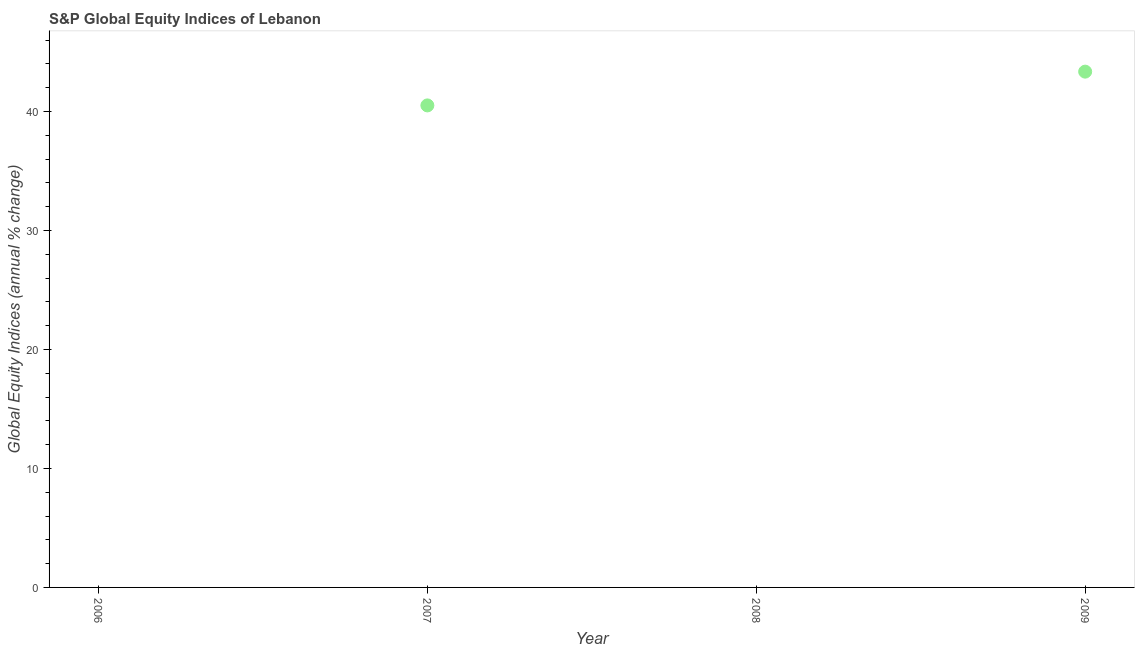Across all years, what is the maximum s&p global equity indices?
Offer a very short reply. 43.36. What is the sum of the s&p global equity indices?
Provide a succinct answer. 83.88. What is the difference between the s&p global equity indices in 2007 and 2009?
Make the answer very short. -2.84. What is the average s&p global equity indices per year?
Make the answer very short. 20.97. What is the median s&p global equity indices?
Your response must be concise. 20.26. In how many years, is the s&p global equity indices greater than 40 %?
Give a very brief answer. 2. What is the ratio of the s&p global equity indices in 2007 to that in 2009?
Offer a very short reply. 0.93. Is the sum of the s&p global equity indices in 2007 and 2009 greater than the maximum s&p global equity indices across all years?
Give a very brief answer. Yes. What is the difference between the highest and the lowest s&p global equity indices?
Your answer should be compact. 43.36. In how many years, is the s&p global equity indices greater than the average s&p global equity indices taken over all years?
Offer a very short reply. 2. Are the values on the major ticks of Y-axis written in scientific E-notation?
Provide a short and direct response. No. What is the title of the graph?
Make the answer very short. S&P Global Equity Indices of Lebanon. What is the label or title of the Y-axis?
Ensure brevity in your answer.  Global Equity Indices (annual % change). What is the Global Equity Indices (annual % change) in 2007?
Provide a succinct answer. 40.52. What is the Global Equity Indices (annual % change) in 2009?
Offer a very short reply. 43.36. What is the difference between the Global Equity Indices (annual % change) in 2007 and 2009?
Make the answer very short. -2.84. What is the ratio of the Global Equity Indices (annual % change) in 2007 to that in 2009?
Ensure brevity in your answer.  0.94. 